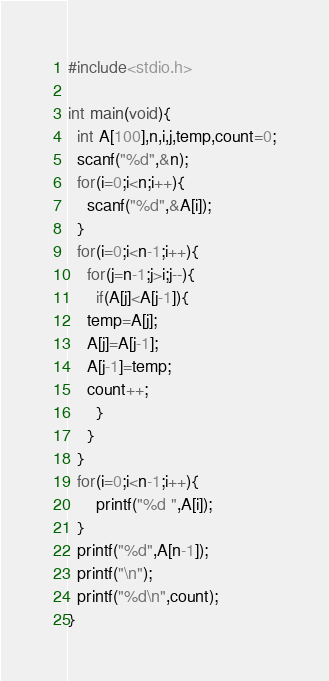<code> <loc_0><loc_0><loc_500><loc_500><_C_>#include<stdio.h>

int main(void){
  int A[100],n,i,j,temp,count=0;
  scanf("%d",&n);
  for(i=0;i<n;i++){
    scanf("%d",&A[i]);
  }
  for(i=0;i<n-1;i++){
    for(j=n-1;j>i;j--){
      if(A[j]<A[j-1]){
	temp=A[j];
	A[j]=A[j-1];
	A[j-1]=temp;
	count++;
      }
    }
  }
  for(i=0;i<n-1;i++){
      printf("%d ",A[i]);
  }
  printf("%d",A[n-1]);
  printf("\n");
  printf("%d\n",count);
}

</code> 